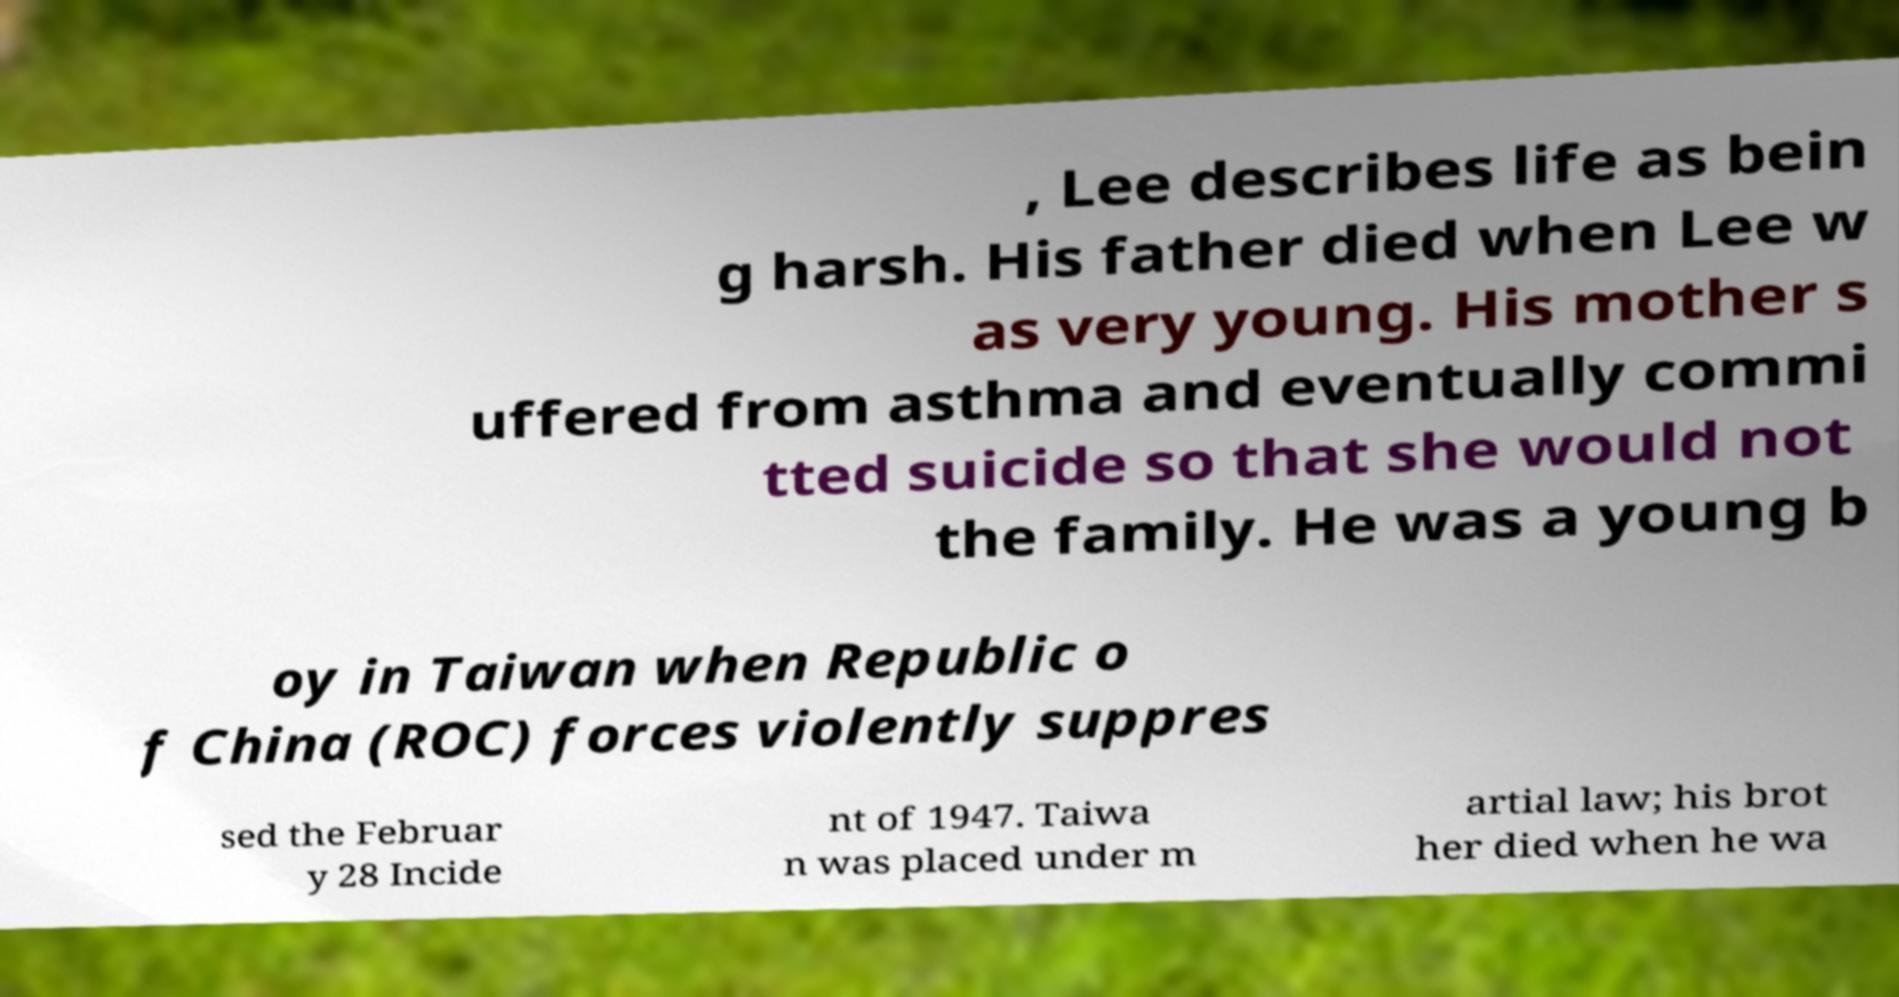What messages or text are displayed in this image? I need them in a readable, typed format. , Lee describes life as bein g harsh. His father died when Lee w as very young. His mother s uffered from asthma and eventually commi tted suicide so that she would not the family. He was a young b oy in Taiwan when Republic o f China (ROC) forces violently suppres sed the Februar y 28 Incide nt of 1947. Taiwa n was placed under m artial law; his brot her died when he wa 